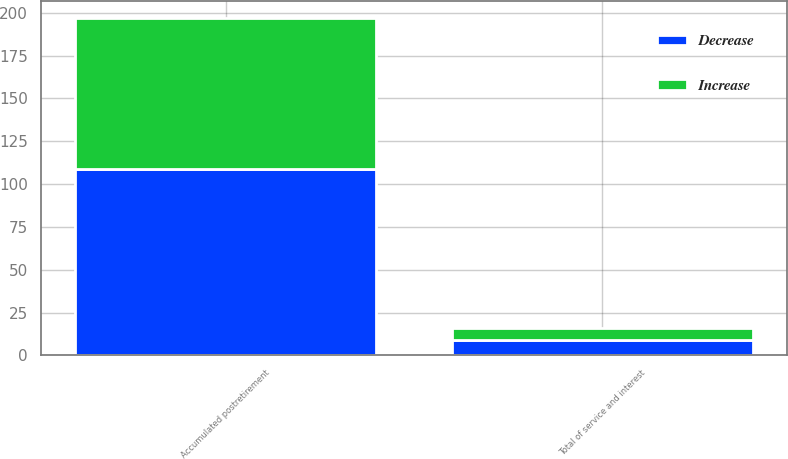Convert chart to OTSL. <chart><loc_0><loc_0><loc_500><loc_500><stacked_bar_chart><ecel><fcel>Accumulated postretirement<fcel>Total of service and interest<nl><fcel>Decrease<fcel>109<fcel>9<nl><fcel>Increase<fcel>88<fcel>7<nl></chart> 